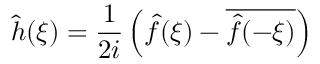<formula> <loc_0><loc_0><loc_500><loc_500>{ \hat { h } } ( \xi ) = { \frac { 1 } { 2 i } } \left ( { \hat { f } } ( \xi ) - { \overline { { { \hat { f } } ( - \xi ) } } } \right )</formula> 